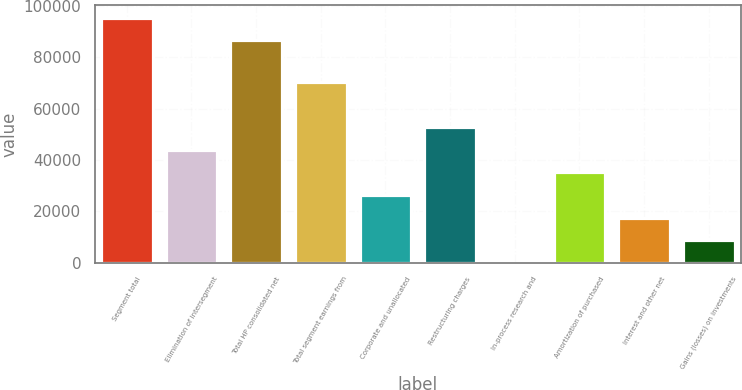Convert chart. <chart><loc_0><loc_0><loc_500><loc_500><bar_chart><fcel>Segment total<fcel>Elimination of intersegment<fcel>Total HP consolidated net<fcel>Total segment earnings from<fcel>Corporate and unallocated<fcel>Restructuring charges<fcel>In-process research and<fcel>Amortization of purchased<fcel>Interest and other net<fcel>Gains (losses) on investments<nl><fcel>95479.3<fcel>43918.5<fcel>86696<fcel>70268.4<fcel>26351.9<fcel>52701.8<fcel>2<fcel>35135.2<fcel>17568.6<fcel>8785.3<nl></chart> 